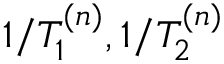<formula> <loc_0><loc_0><loc_500><loc_500>1 / T _ { 1 } ^ { ( n ) } , 1 / T _ { 2 } ^ { ( n ) }</formula> 